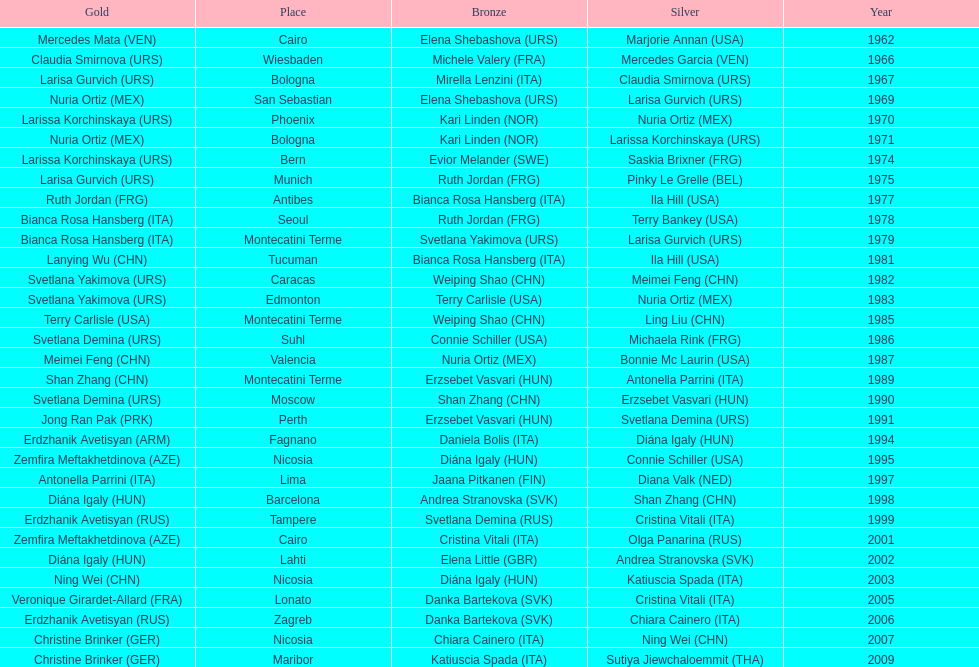Which country has the most bronze medals? Italy. 